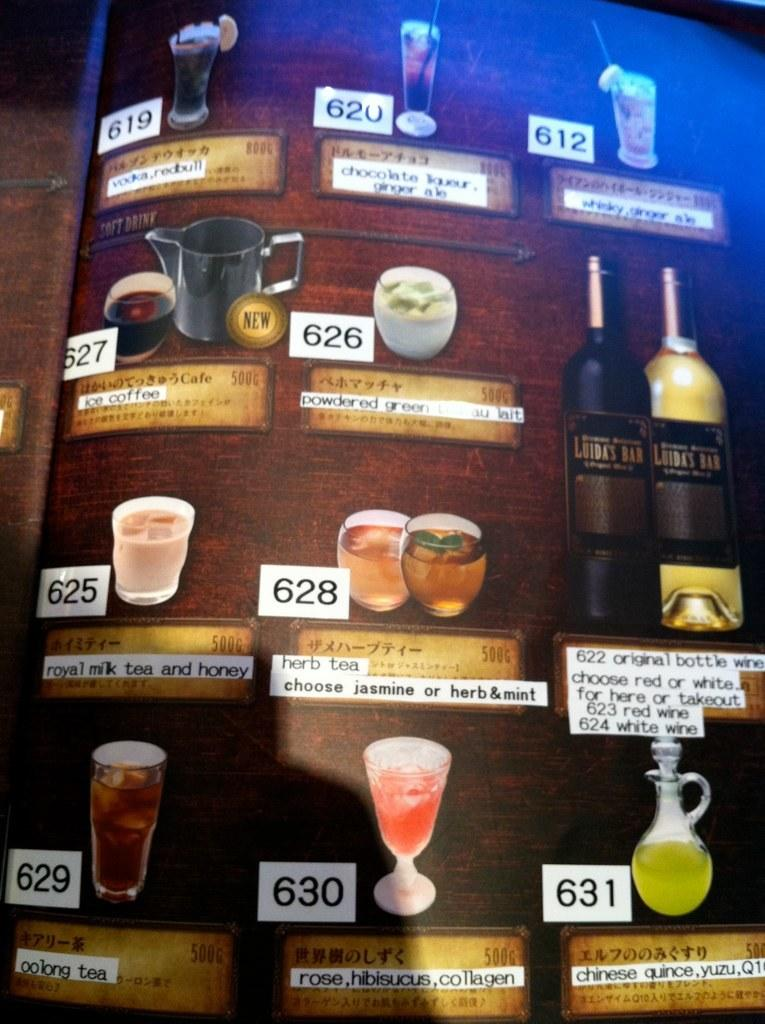<image>
Present a compact description of the photo's key features. a drink menu board for things like Herb Tea and Ice Coffee 